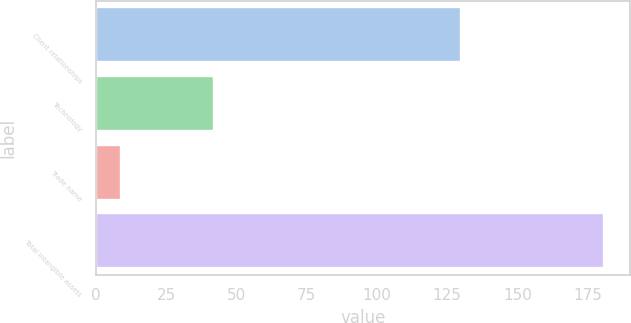<chart> <loc_0><loc_0><loc_500><loc_500><bar_chart><fcel>Client relationships<fcel>Technology<fcel>Trade name<fcel>Total intangible assets<nl><fcel>130<fcel>42<fcel>9<fcel>181<nl></chart> 